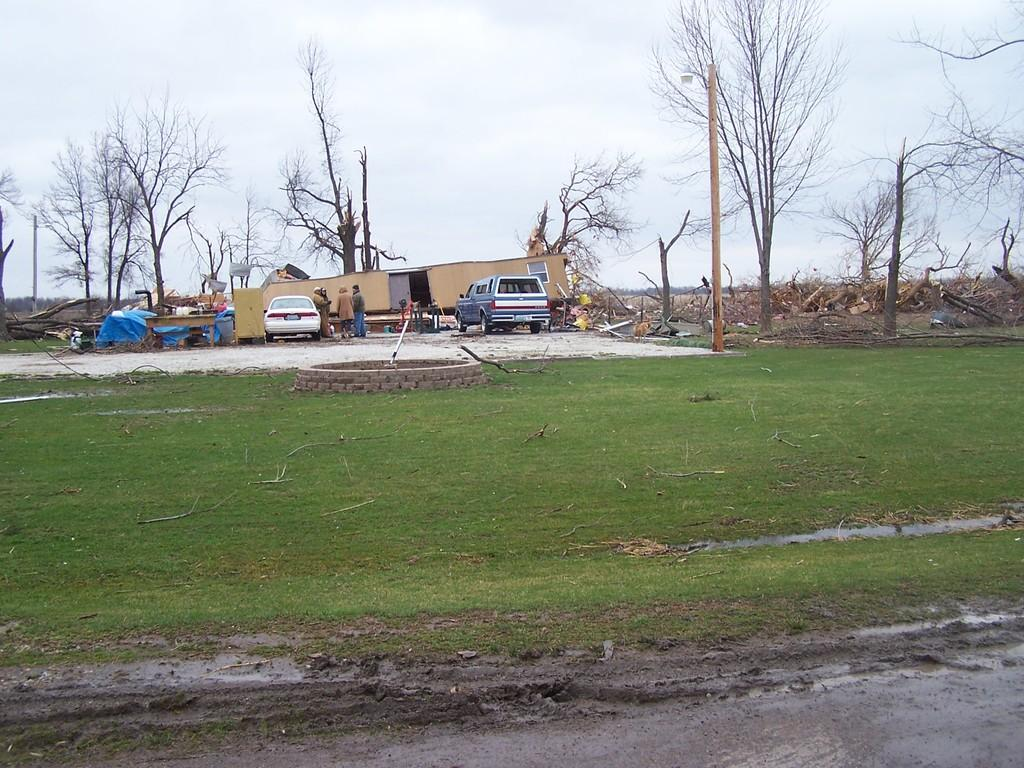What types of objects can be seen in the image? There are vehicles, dry trees, people, wooden sticks, a table, and objects on the ground in the image. What is the color of the sky in the image? The sky is in white and blue color in the image. What type of vegetation is present in the image? Green grass is present in the image. What song is being sung by the crowd in the image? There is no crowd present in the image, and therefore no song can be heard or sung. What type of bushes can be seen in the image? There are no bushes present in the image; only dry trees and green grass are visible. 